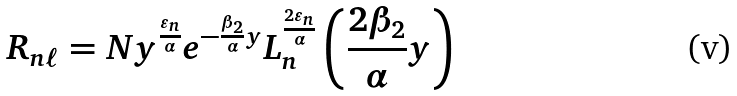Convert formula to latex. <formula><loc_0><loc_0><loc_500><loc_500>R _ { n \ell } = N y ^ { \frac { \varepsilon _ { n } } { \alpha } } e ^ { - \frac { \beta _ { 2 } } { \alpha } y } L _ { n } ^ { \frac { 2 \varepsilon _ { n } } { \alpha } } \left ( \frac { 2 \beta _ { 2 } } { \alpha } y \right )</formula> 